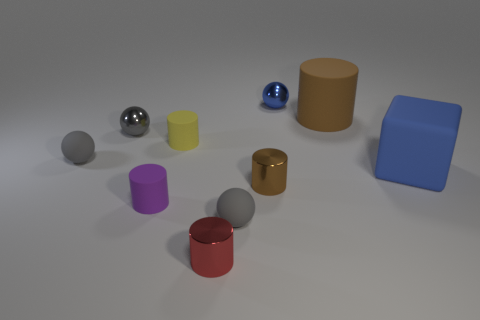Is the material of the small yellow cylinder the same as the small red cylinder?
Make the answer very short. No. What number of blue shiny balls are in front of the large thing behind the large matte block?
Offer a very short reply. 0. There is a tiny gray thing right of the tiny gray shiny object; is it the same shape as the gray matte object behind the blue rubber cube?
Your response must be concise. Yes. What shape is the object that is the same color as the big cylinder?
Your response must be concise. Cylinder. Is there a tiny yellow thing that has the same material as the big blue block?
Give a very brief answer. Yes. What number of metallic things are either small blue balls or large objects?
Provide a short and direct response. 1. The small red shiny object that is in front of the tiny yellow cylinder in front of the small blue metallic sphere is what shape?
Provide a short and direct response. Cylinder. Are there fewer small metallic things that are behind the blue rubber cube than big blue rubber cubes?
Make the answer very short. No. What is the shape of the tiny purple object?
Your response must be concise. Cylinder. There is a cylinder right of the blue metallic object; what is its size?
Keep it short and to the point. Large. 